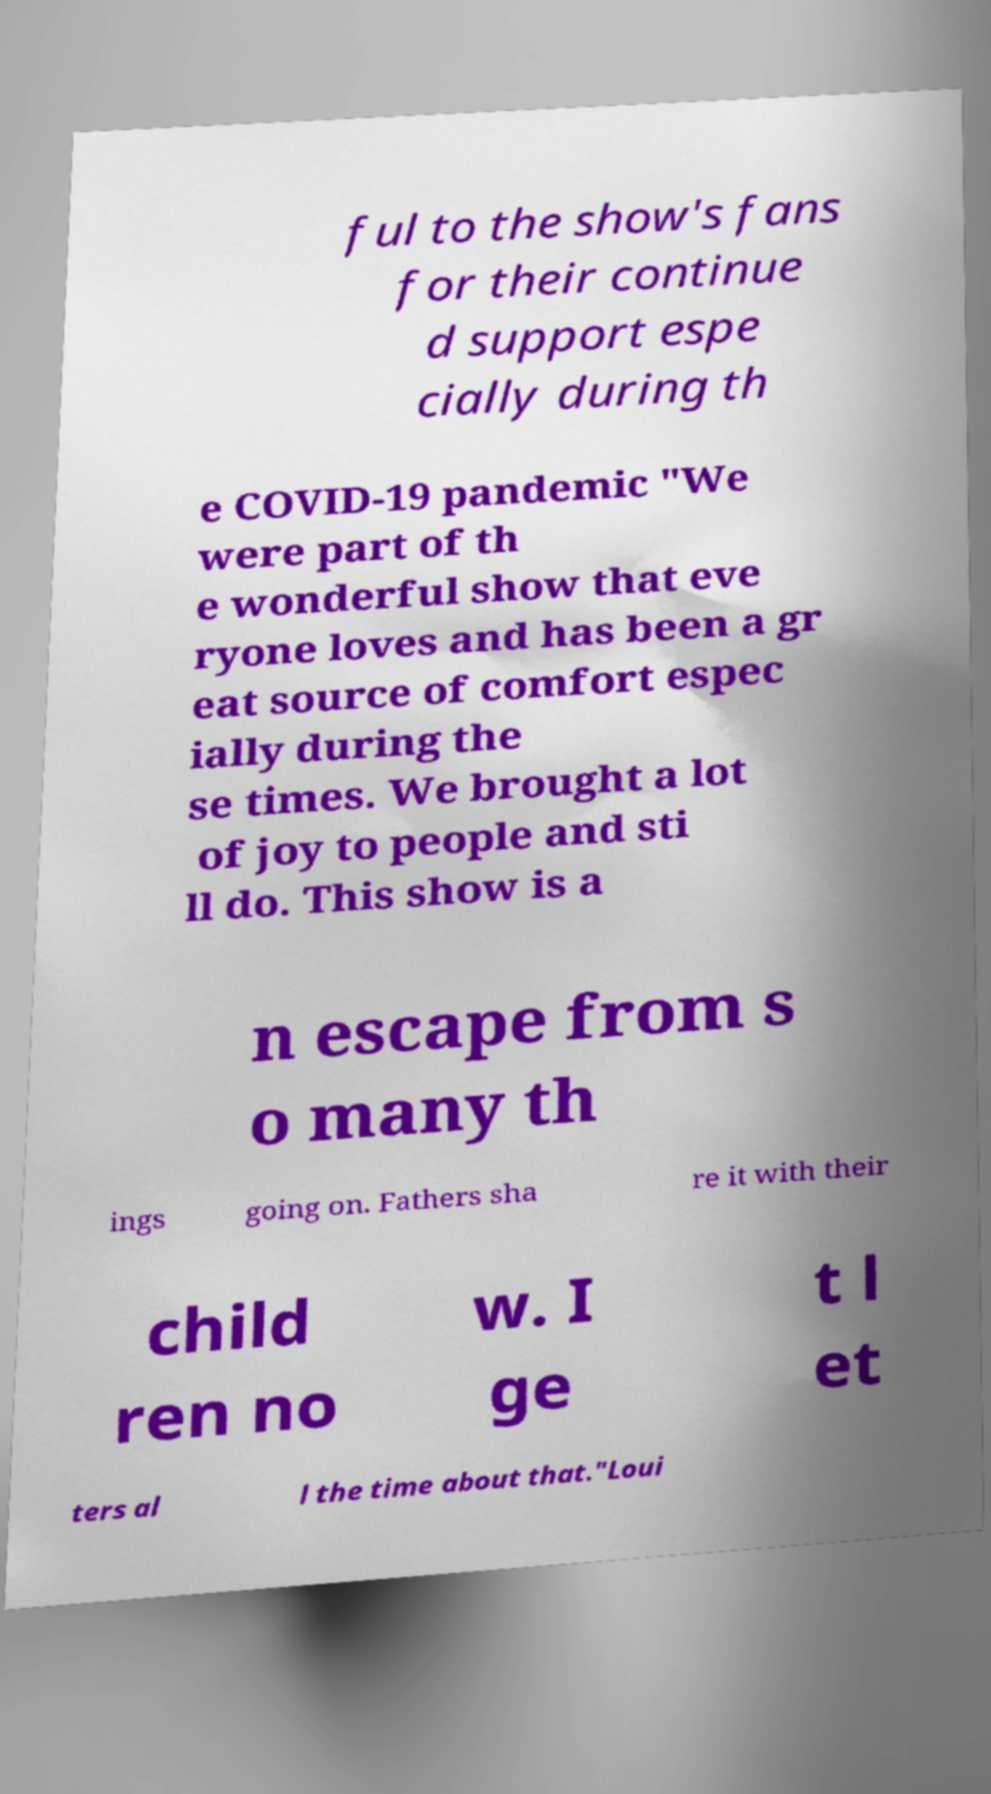There's text embedded in this image that I need extracted. Can you transcribe it verbatim? ful to the show's fans for their continue d support espe cially during th e COVID-19 pandemic "We were part of th e wonderful show that eve ryone loves and has been a gr eat source of comfort espec ially during the se times. We brought a lot of joy to people and sti ll do. This show is a n escape from s o many th ings going on. Fathers sha re it with their child ren no w. I ge t l et ters al l the time about that."Loui 